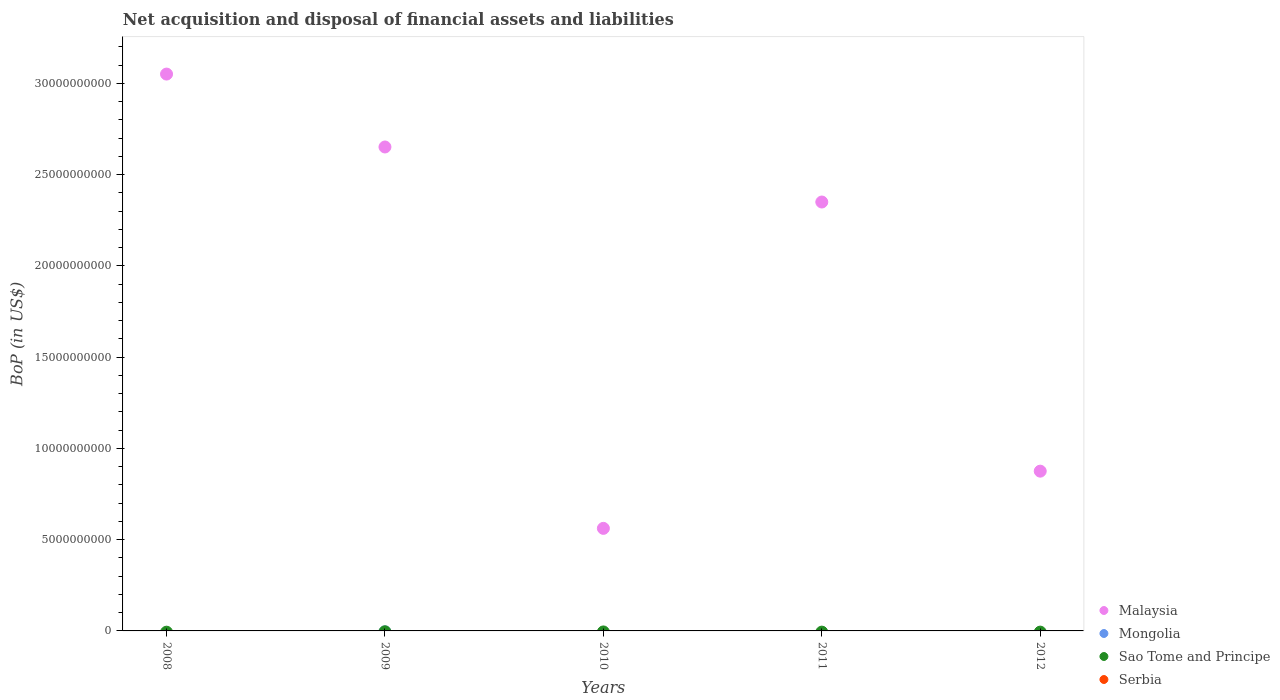How many different coloured dotlines are there?
Offer a very short reply. 1. What is the Balance of Payments in Malaysia in 2008?
Provide a succinct answer. 3.05e+1. What is the difference between the Balance of Payments in Malaysia in 2009 and that in 2010?
Provide a succinct answer. 2.09e+1. What is the difference between the Balance of Payments in Malaysia in 2011 and the Balance of Payments in Sao Tome and Principe in 2008?
Your response must be concise. 2.35e+1. What is the ratio of the Balance of Payments in Malaysia in 2008 to that in 2011?
Keep it short and to the point. 1.3. What is the difference between the highest and the second highest Balance of Payments in Malaysia?
Your answer should be very brief. 3.99e+09. In how many years, is the Balance of Payments in Malaysia greater than the average Balance of Payments in Malaysia taken over all years?
Offer a very short reply. 3. Is the sum of the Balance of Payments in Malaysia in 2010 and 2011 greater than the maximum Balance of Payments in Mongolia across all years?
Provide a succinct answer. Yes. Is it the case that in every year, the sum of the Balance of Payments in Malaysia and Balance of Payments in Mongolia  is greater than the sum of Balance of Payments in Serbia and Balance of Payments in Sao Tome and Principe?
Give a very brief answer. Yes. How many dotlines are there?
Provide a short and direct response. 1. Are the values on the major ticks of Y-axis written in scientific E-notation?
Offer a terse response. No. Where does the legend appear in the graph?
Your answer should be very brief. Bottom right. How many legend labels are there?
Offer a very short reply. 4. What is the title of the graph?
Ensure brevity in your answer.  Net acquisition and disposal of financial assets and liabilities. Does "Italy" appear as one of the legend labels in the graph?
Give a very brief answer. No. What is the label or title of the X-axis?
Keep it short and to the point. Years. What is the label or title of the Y-axis?
Ensure brevity in your answer.  BoP (in US$). What is the BoP (in US$) in Malaysia in 2008?
Your response must be concise. 3.05e+1. What is the BoP (in US$) in Malaysia in 2009?
Provide a succinct answer. 2.65e+1. What is the BoP (in US$) of Malaysia in 2010?
Make the answer very short. 5.62e+09. What is the BoP (in US$) in Mongolia in 2010?
Offer a very short reply. 0. What is the BoP (in US$) in Sao Tome and Principe in 2010?
Keep it short and to the point. 0. What is the BoP (in US$) of Serbia in 2010?
Your answer should be compact. 0. What is the BoP (in US$) in Malaysia in 2011?
Offer a terse response. 2.35e+1. What is the BoP (in US$) of Malaysia in 2012?
Make the answer very short. 8.75e+09. What is the BoP (in US$) in Mongolia in 2012?
Your answer should be very brief. 0. What is the BoP (in US$) of Serbia in 2012?
Your response must be concise. 0. Across all years, what is the maximum BoP (in US$) in Malaysia?
Ensure brevity in your answer.  3.05e+1. Across all years, what is the minimum BoP (in US$) in Malaysia?
Make the answer very short. 5.62e+09. What is the total BoP (in US$) in Malaysia in the graph?
Keep it short and to the point. 9.49e+1. What is the total BoP (in US$) in Mongolia in the graph?
Your response must be concise. 0. What is the total BoP (in US$) of Sao Tome and Principe in the graph?
Make the answer very short. 0. What is the total BoP (in US$) in Serbia in the graph?
Offer a very short reply. 0. What is the difference between the BoP (in US$) of Malaysia in 2008 and that in 2009?
Provide a short and direct response. 3.99e+09. What is the difference between the BoP (in US$) in Malaysia in 2008 and that in 2010?
Offer a very short reply. 2.49e+1. What is the difference between the BoP (in US$) of Malaysia in 2008 and that in 2011?
Your answer should be very brief. 7.01e+09. What is the difference between the BoP (in US$) in Malaysia in 2008 and that in 2012?
Your response must be concise. 2.18e+1. What is the difference between the BoP (in US$) in Malaysia in 2009 and that in 2010?
Offer a very short reply. 2.09e+1. What is the difference between the BoP (in US$) of Malaysia in 2009 and that in 2011?
Keep it short and to the point. 3.02e+09. What is the difference between the BoP (in US$) in Malaysia in 2009 and that in 2012?
Keep it short and to the point. 1.78e+1. What is the difference between the BoP (in US$) of Malaysia in 2010 and that in 2011?
Offer a very short reply. -1.79e+1. What is the difference between the BoP (in US$) of Malaysia in 2010 and that in 2012?
Your response must be concise. -3.13e+09. What is the difference between the BoP (in US$) of Malaysia in 2011 and that in 2012?
Keep it short and to the point. 1.47e+1. What is the average BoP (in US$) in Malaysia per year?
Your answer should be compact. 1.90e+1. What is the average BoP (in US$) of Mongolia per year?
Keep it short and to the point. 0. What is the average BoP (in US$) in Sao Tome and Principe per year?
Your answer should be very brief. 0. What is the average BoP (in US$) in Serbia per year?
Make the answer very short. 0. What is the ratio of the BoP (in US$) in Malaysia in 2008 to that in 2009?
Ensure brevity in your answer.  1.15. What is the ratio of the BoP (in US$) of Malaysia in 2008 to that in 2010?
Make the answer very short. 5.43. What is the ratio of the BoP (in US$) in Malaysia in 2008 to that in 2011?
Your response must be concise. 1.3. What is the ratio of the BoP (in US$) in Malaysia in 2008 to that in 2012?
Provide a succinct answer. 3.49. What is the ratio of the BoP (in US$) in Malaysia in 2009 to that in 2010?
Your answer should be compact. 4.72. What is the ratio of the BoP (in US$) in Malaysia in 2009 to that in 2011?
Ensure brevity in your answer.  1.13. What is the ratio of the BoP (in US$) of Malaysia in 2009 to that in 2012?
Your answer should be very brief. 3.03. What is the ratio of the BoP (in US$) in Malaysia in 2010 to that in 2011?
Your response must be concise. 0.24. What is the ratio of the BoP (in US$) of Malaysia in 2010 to that in 2012?
Keep it short and to the point. 0.64. What is the ratio of the BoP (in US$) in Malaysia in 2011 to that in 2012?
Your response must be concise. 2.68. What is the difference between the highest and the second highest BoP (in US$) in Malaysia?
Make the answer very short. 3.99e+09. What is the difference between the highest and the lowest BoP (in US$) of Malaysia?
Ensure brevity in your answer.  2.49e+1. 